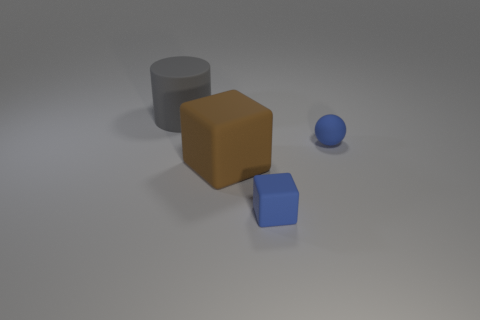Does the blue object behind the blue matte block have the same size as the block that is left of the tiny blue rubber cube? no 